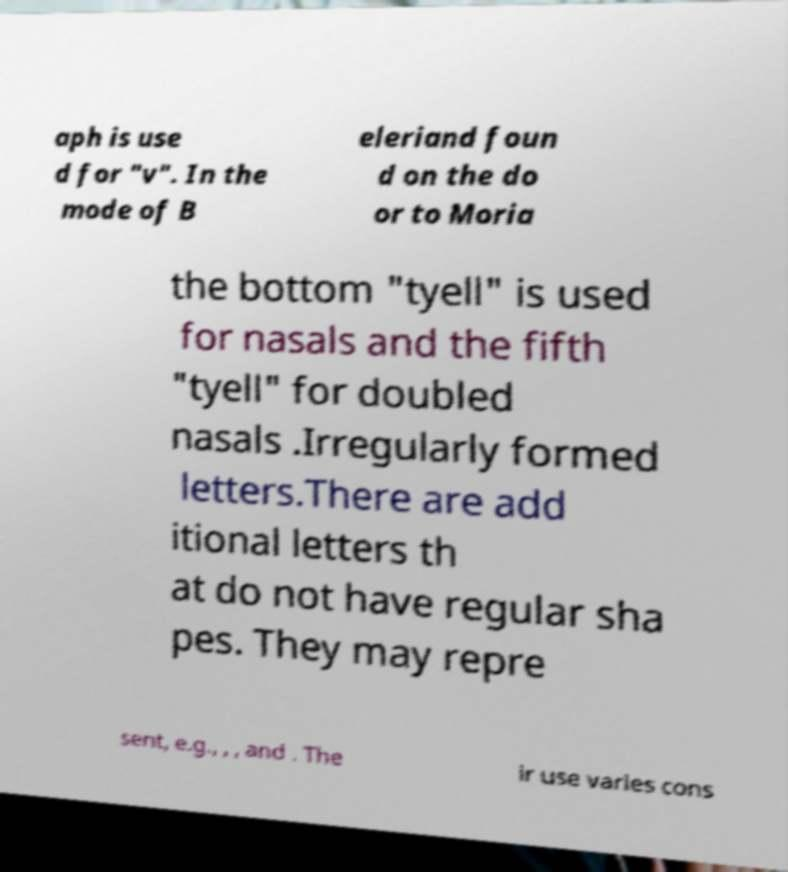Can you accurately transcribe the text from the provided image for me? aph is use d for "v". In the mode of B eleriand foun d on the do or to Moria the bottom "tyell" is used for nasals and the fifth "tyell" for doubled nasals .Irregularly formed letters.There are add itional letters th at do not have regular sha pes. They may repre sent, e.g., , , and . The ir use varies cons 